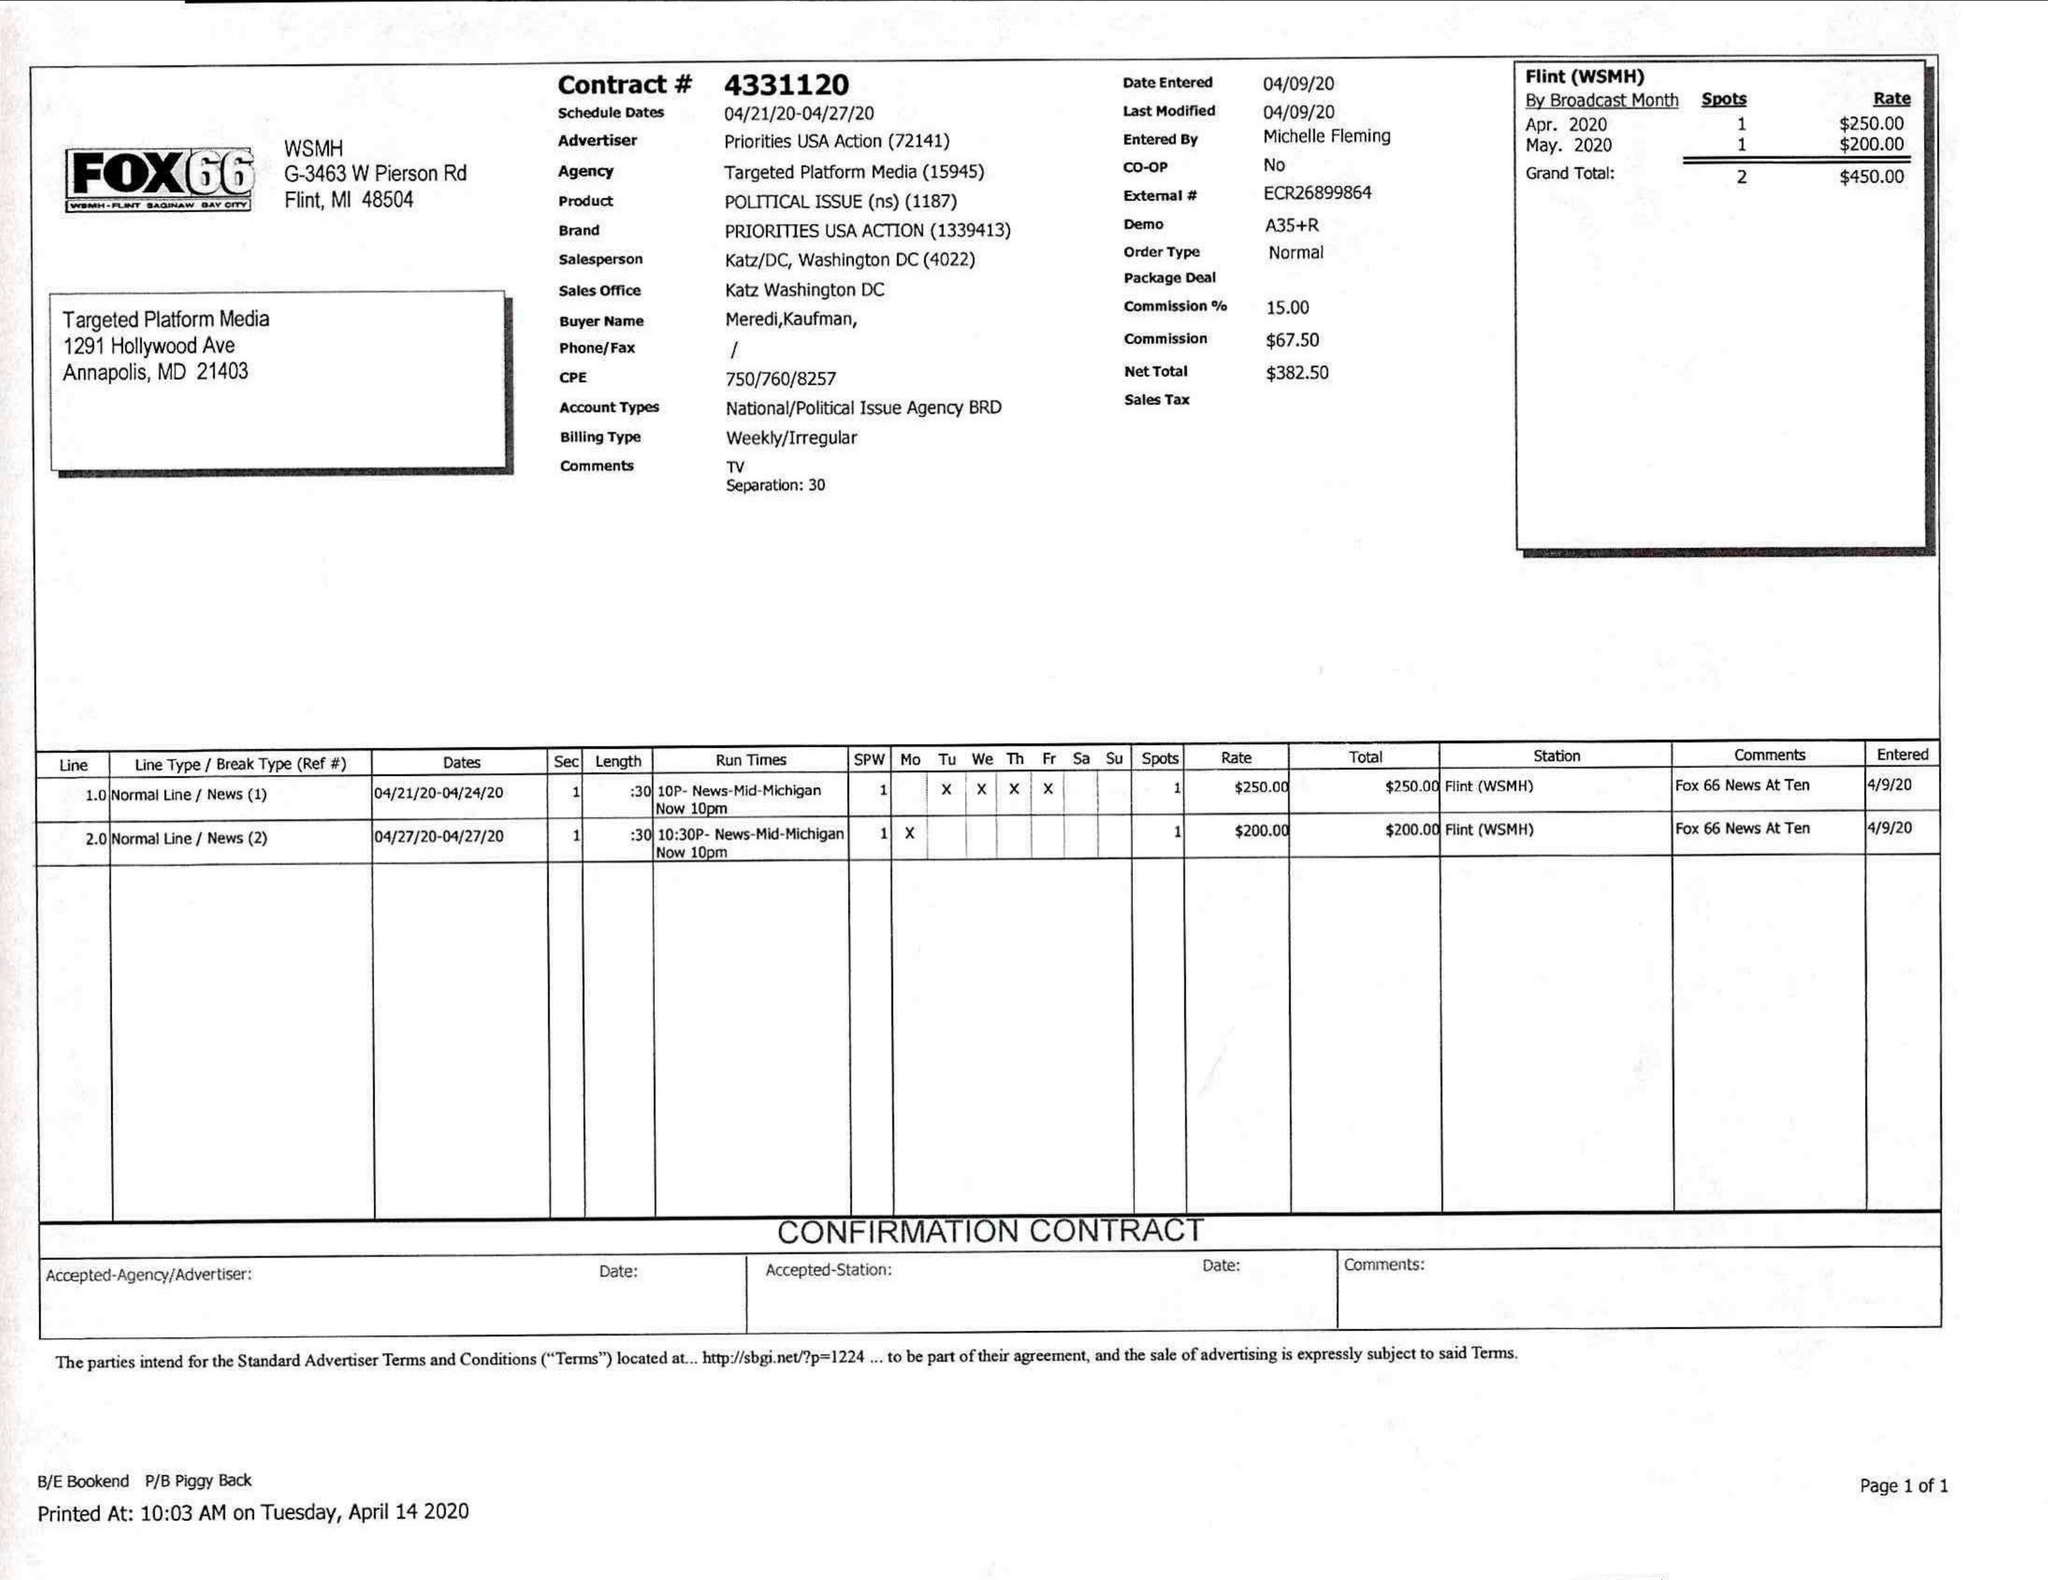What is the value for the flight_to?
Answer the question using a single word or phrase. 04/27/20 